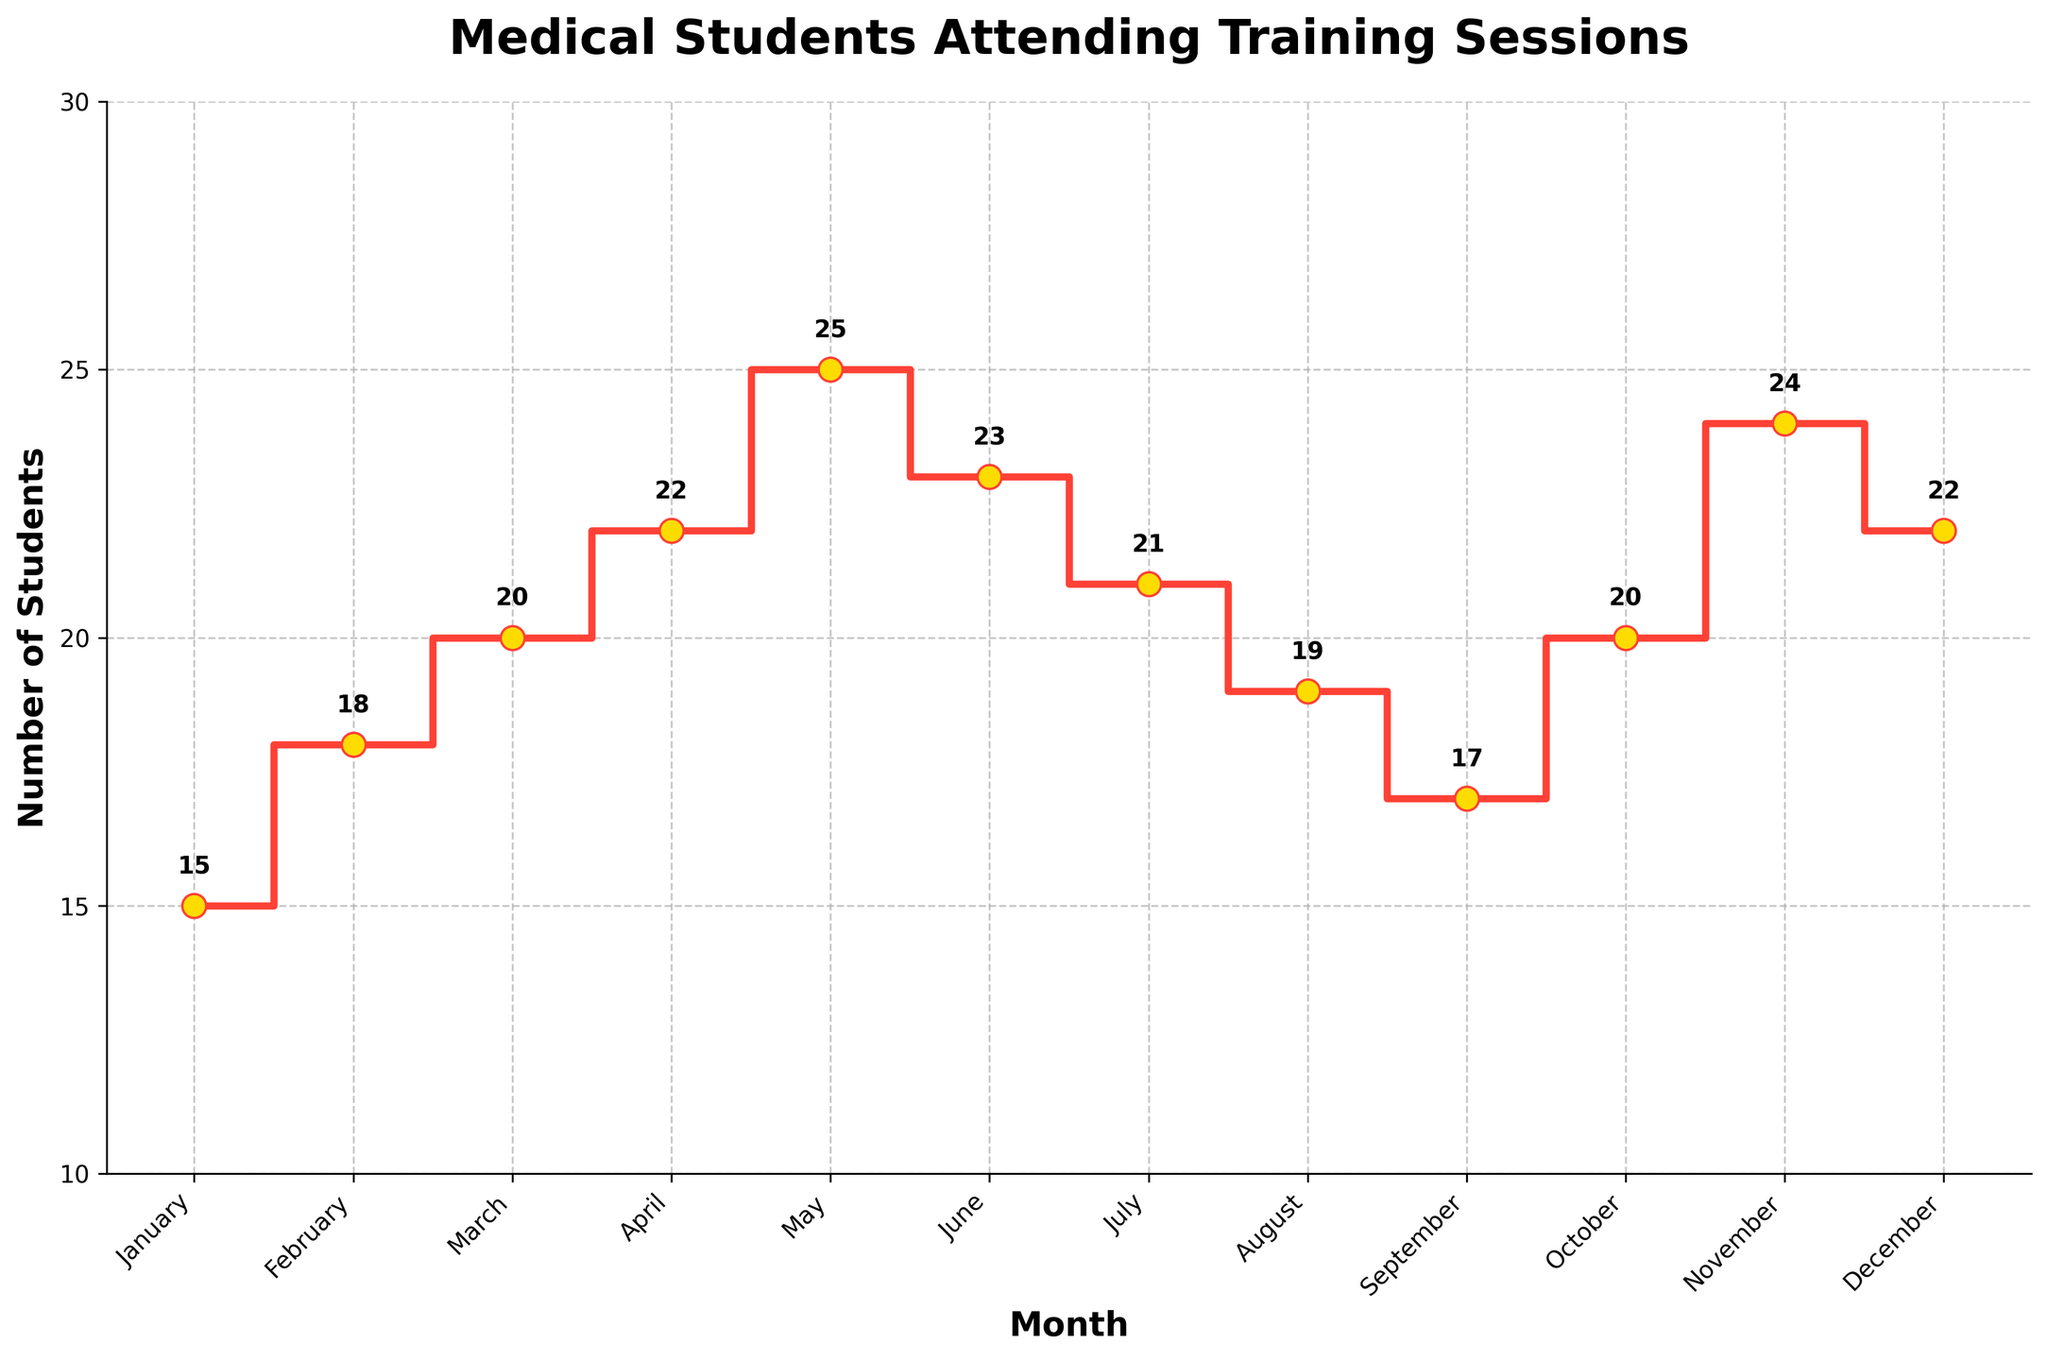What is the title of the figure? The title of the figure is located at the top and summarizes the main focus of the plot. It reads 'Medical Students Attending Training Sessions'.
Answer: Medical Students Attending Training Sessions Which month had the highest number of students attending training sessions? To find this, look for the point with the highest y-coordinate on the stair plot. The highest point, at 25 students, is in May.
Answer: May What was the number of students who attended the Mental Health Support Workshop in April? This value can be read directly off the y-axis corresponding to the stair step for April. The number is 22.
Answer: 22 How many students attended the training sessions in the first quarter of the year (January, February, March)? Add the student numbers for January (15), February (18), and March (20). 15 + 18 + 20 = 53.
Answer: 53 Compare the number of students attended in June (Field Surgery Techniques) and October (Advanced Life Support). Which month had more students and by how many? The number of students in June was 23 and in October was 20. The difference is 23 - 20 = 3. June had 3 more students than October.
Answer: June, 3 Which training session had the lowest number of students attending, and how many attended? Look for the lowest point on the y-axis. The lowest attendance of 15 students was during the First Aid Training session in January.
Answer: First Aid Training, 15 What was the total number of students who attended training sessions in the second half of the year (July to December)? Add the student numbers for July (21), August (19), September (17), October (20), November (24), and December (22). 21 + 19 + 17 + 20 + 24 + 22 = 123.
Answer: 123 Between which consecutive months did the number of students attending training sessions increase the most? Calculate the differences between consecutive months and find the largest increase. The significant increase occurred from April (22) to May (25). The difference is 25 - 22 = 3.
Answer: April to May What is the overall trend in the number of students attending sessions from January to December—generally increasing, decreasing, or mixed? Observing the stair plot, although there are fluctuations, the general trend shows a gradual increase with a few periods of decline.
Answer: Mixed What is the average number of students attending training sessions per month over the entire year? Sum all the attendance numbers and divide by 12 (number of months): (15 + 18 + 20 + 22 + 25 + 23 + 21 + 19 + 17 + 20 + 24 + 22) / 12 = 20.25.
Answer: 20.25 